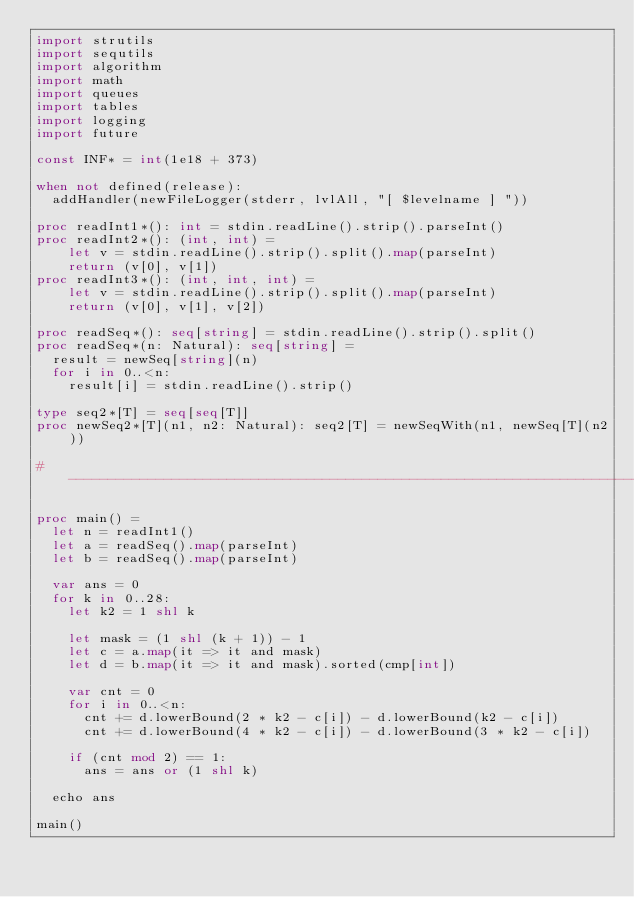<code> <loc_0><loc_0><loc_500><loc_500><_Nim_>import strutils
import sequtils
import algorithm
import math
import queues
import tables
import logging
import future

const INF* = int(1e18 + 373)

when not defined(release):
  addHandler(newFileLogger(stderr, lvlAll, "[ $levelname ] "))

proc readInt1*(): int = stdin.readLine().strip().parseInt()
proc readInt2*(): (int, int) =
    let v = stdin.readLine().strip().split().map(parseInt)
    return (v[0], v[1])
proc readInt3*(): (int, int, int) =
    let v = stdin.readLine().strip().split().map(parseInt)
    return (v[0], v[1], v[2])

proc readSeq*(): seq[string] = stdin.readLine().strip().split()
proc readSeq*(n: Natural): seq[string] =
  result = newSeq[string](n)
  for i in 0..<n:
    result[i] = stdin.readLine().strip()

type seq2*[T] = seq[seq[T]]
proc newSeq2*[T](n1, n2: Natural): seq2[T] = newSeqWith(n1, newSeq[T](n2))

#------------------------------------------------------------------------------#

proc main() =
  let n = readInt1()
  let a = readSeq().map(parseInt)
  let b = readSeq().map(parseInt)

  var ans = 0
  for k in 0..28:
    let k2 = 1 shl k

    let mask = (1 shl (k + 1)) - 1
    let c = a.map(it => it and mask)
    let d = b.map(it => it and mask).sorted(cmp[int])

    var cnt = 0
    for i in 0..<n:
      cnt += d.lowerBound(2 * k2 - c[i]) - d.lowerBound(k2 - c[i])
      cnt += d.lowerBound(4 * k2 - c[i]) - d.lowerBound(3 * k2 - c[i])

    if (cnt mod 2) == 1:
      ans = ans or (1 shl k)

  echo ans

main()

</code> 